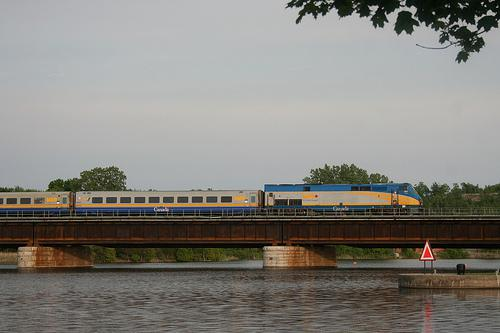Question: what is surrounded around body of water?
Choices:
A. Trees.
B. A park.
C. A pasture.
D. Gardens.
Answer with the letter. Answer: A Question: why would the red be up?
Choices:
A. Caution.
B. Danger.
C. Signal to stop.
D. Warning.
Answer with the letter. Answer: A Question: what is the bridge over?
Choices:
A. A river.
B. A canyon.
C. Water.
D. A railroad track.
Answer with the letter. Answer: C Question: how many train carts do you see?
Choices:
A. Two.
B. Five.
C. Three.
D. Six.
Answer with the letter. Answer: C Question: where is the train?
Choices:
A. On a trestle.
B. At the station.
C. On tracks.
D. Crossing the river.
Answer with the letter. Answer: C 